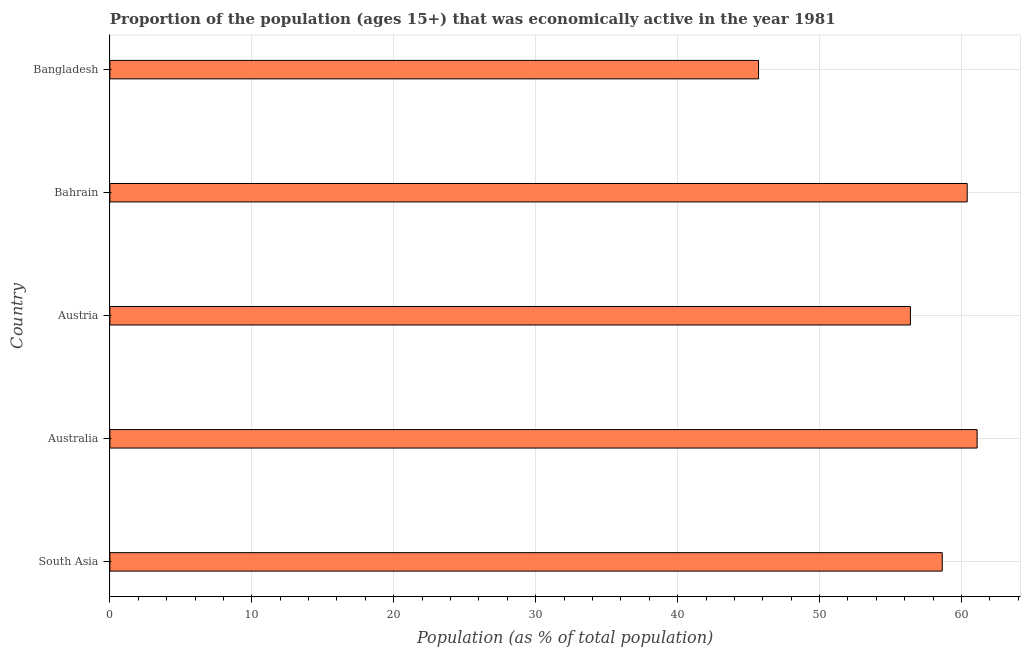Does the graph contain any zero values?
Offer a very short reply. No. What is the title of the graph?
Keep it short and to the point. Proportion of the population (ages 15+) that was economically active in the year 1981. What is the label or title of the X-axis?
Provide a short and direct response. Population (as % of total population). What is the label or title of the Y-axis?
Give a very brief answer. Country. What is the percentage of economically active population in South Asia?
Offer a very short reply. 58.64. Across all countries, what is the maximum percentage of economically active population?
Make the answer very short. 61.1. Across all countries, what is the minimum percentage of economically active population?
Provide a succinct answer. 45.7. What is the sum of the percentage of economically active population?
Offer a very short reply. 282.24. What is the difference between the percentage of economically active population in Australia and Austria?
Make the answer very short. 4.7. What is the average percentage of economically active population per country?
Offer a very short reply. 56.45. What is the median percentage of economically active population?
Keep it short and to the point. 58.64. In how many countries, is the percentage of economically active population greater than 24 %?
Your response must be concise. 5. What is the ratio of the percentage of economically active population in Bahrain to that in Bangladesh?
Keep it short and to the point. 1.32. How many bars are there?
Offer a very short reply. 5. Are all the bars in the graph horizontal?
Keep it short and to the point. Yes. How many countries are there in the graph?
Your answer should be compact. 5. What is the difference between two consecutive major ticks on the X-axis?
Provide a short and direct response. 10. What is the Population (as % of total population) in South Asia?
Your response must be concise. 58.64. What is the Population (as % of total population) of Australia?
Your answer should be very brief. 61.1. What is the Population (as % of total population) of Austria?
Ensure brevity in your answer.  56.4. What is the Population (as % of total population) of Bahrain?
Your response must be concise. 60.4. What is the Population (as % of total population) of Bangladesh?
Provide a short and direct response. 45.7. What is the difference between the Population (as % of total population) in South Asia and Australia?
Offer a terse response. -2.46. What is the difference between the Population (as % of total population) in South Asia and Austria?
Offer a terse response. 2.24. What is the difference between the Population (as % of total population) in South Asia and Bahrain?
Ensure brevity in your answer.  -1.76. What is the difference between the Population (as % of total population) in South Asia and Bangladesh?
Offer a terse response. 12.94. What is the difference between the Population (as % of total population) in Australia and Bahrain?
Give a very brief answer. 0.7. What is the difference between the Population (as % of total population) in Austria and Bahrain?
Offer a very short reply. -4. What is the difference between the Population (as % of total population) in Austria and Bangladesh?
Provide a short and direct response. 10.7. What is the ratio of the Population (as % of total population) in South Asia to that in Austria?
Keep it short and to the point. 1.04. What is the ratio of the Population (as % of total population) in South Asia to that in Bahrain?
Make the answer very short. 0.97. What is the ratio of the Population (as % of total population) in South Asia to that in Bangladesh?
Make the answer very short. 1.28. What is the ratio of the Population (as % of total population) in Australia to that in Austria?
Provide a short and direct response. 1.08. What is the ratio of the Population (as % of total population) in Australia to that in Bangladesh?
Keep it short and to the point. 1.34. What is the ratio of the Population (as % of total population) in Austria to that in Bahrain?
Make the answer very short. 0.93. What is the ratio of the Population (as % of total population) in Austria to that in Bangladesh?
Offer a very short reply. 1.23. What is the ratio of the Population (as % of total population) in Bahrain to that in Bangladesh?
Keep it short and to the point. 1.32. 